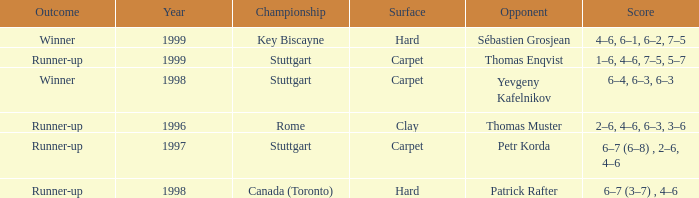What was the outcome before 1997? Runner-up. 